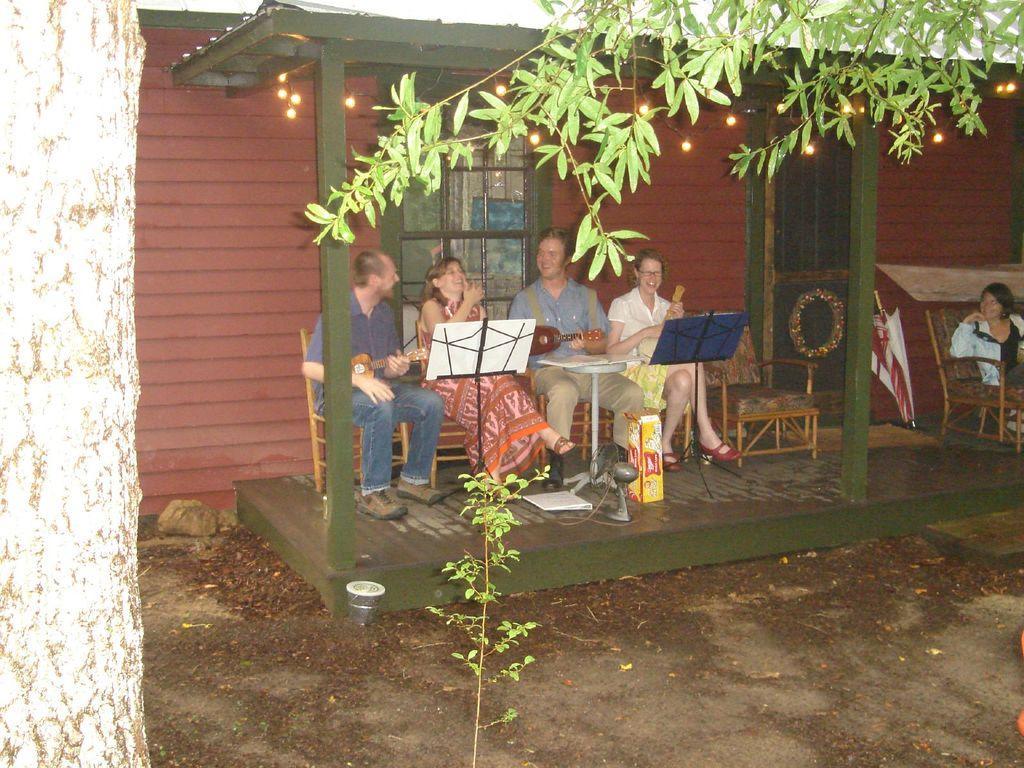Could you give a brief overview of what you see in this image? In this image I can see a tree trunk on the left side and on the top right side of this image I can see leaves. I can also see a plant in the front and in the background I can see a house and number of people are sitting on chairs. I can also see most of them are holding musical instruments and in the front of them I can see two stands, a table, a box and few other things. Behind them I can see a window and on the right side I can see an empty chair, a door and an umbrella. On the top side of this image I can see number of lights. 